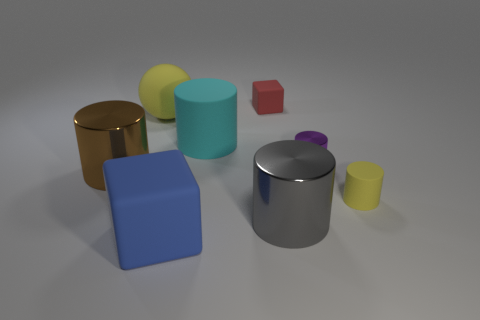There is a gray metallic thing that is the same size as the yellow rubber ball; what shape is it?
Ensure brevity in your answer.  Cylinder. Is there a yellow rubber thing that has the same shape as the big brown object?
Make the answer very short. Yes. The big metal thing that is on the left side of the yellow matte thing on the left side of the big blue object is what shape?
Provide a short and direct response. Cylinder. What is the shape of the blue matte object?
Offer a terse response. Cube. The block behind the large matte cube that is in front of the rubber cylinder that is to the left of the small yellow cylinder is made of what material?
Provide a short and direct response. Rubber. What number of other objects are the same material as the large sphere?
Your response must be concise. 4. There is a large rubber object that is on the left side of the big blue rubber thing; how many rubber things are behind it?
Make the answer very short. 1. What number of cylinders are either large gray rubber things or gray shiny things?
Provide a succinct answer. 1. The big cylinder that is to the left of the red object and on the right side of the brown metal cylinder is what color?
Your response must be concise. Cyan. Are there any other things that have the same color as the large matte cube?
Your answer should be compact. No. 